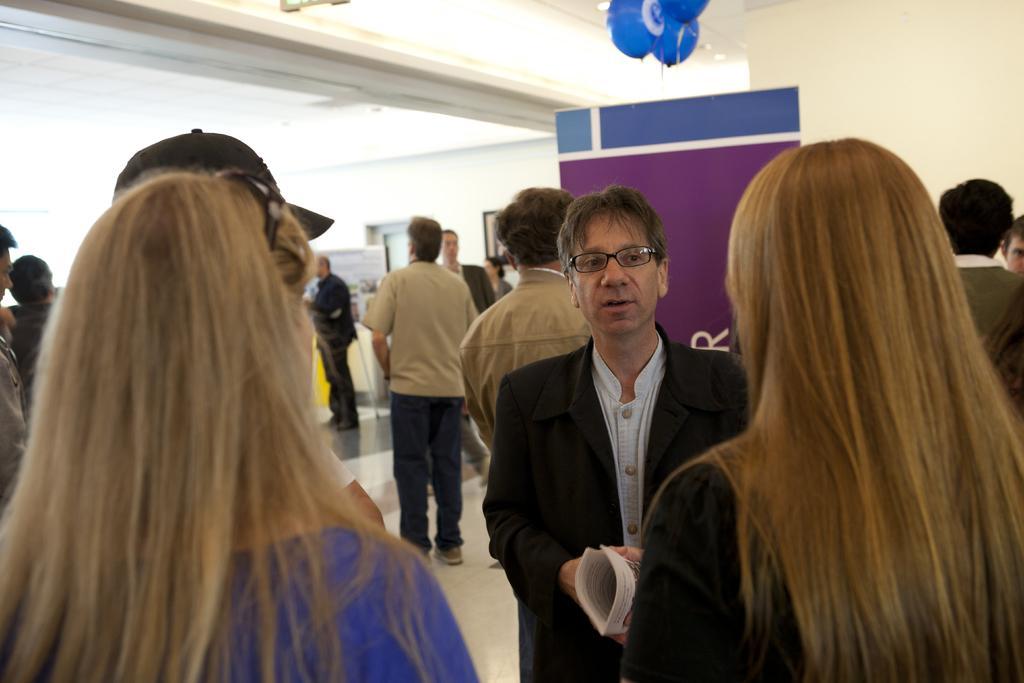Describe this image in one or two sentences. In this image there is a person wearing a blazer. He is holding the book. Few people are standing on the floor. Few frames are attached to the wall. Top of the image there are few balloons. Right side there is a board. 